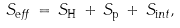Convert formula to latex. <formula><loc_0><loc_0><loc_500><loc_500>S _ { \text  eff}\,=\,S_{\text  H}\,+\,S_{\text  p}\,+\,S_{\text  int},</formula> 